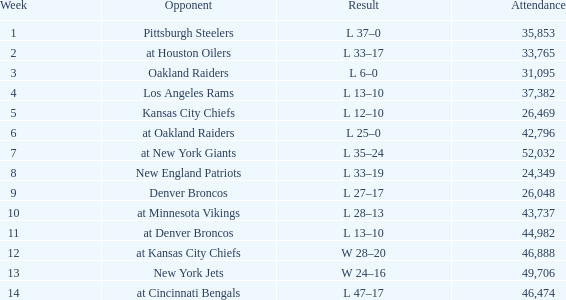What is the earliest week when the outcome was 13-10, november 30, 1975, with over 44,982 individuals present? None. 